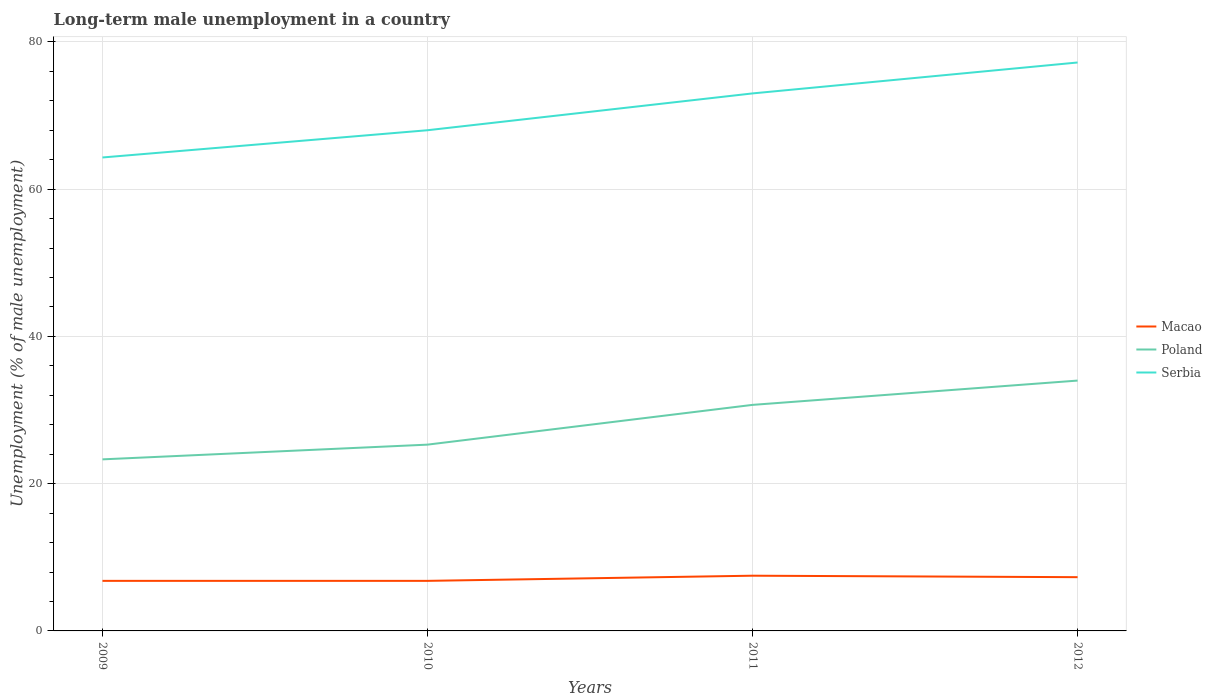Does the line corresponding to Poland intersect with the line corresponding to Macao?
Your answer should be very brief. No. Is the number of lines equal to the number of legend labels?
Offer a very short reply. Yes. Across all years, what is the maximum percentage of long-term unemployed male population in Serbia?
Your answer should be very brief. 64.3. In which year was the percentage of long-term unemployed male population in Serbia maximum?
Offer a very short reply. 2009. What is the total percentage of long-term unemployed male population in Macao in the graph?
Offer a very short reply. -0.7. What is the difference between the highest and the second highest percentage of long-term unemployed male population in Serbia?
Your response must be concise. 12.9. How many lines are there?
Offer a very short reply. 3. How many years are there in the graph?
Provide a succinct answer. 4. What is the difference between two consecutive major ticks on the Y-axis?
Your answer should be very brief. 20. Where does the legend appear in the graph?
Offer a terse response. Center right. How many legend labels are there?
Keep it short and to the point. 3. What is the title of the graph?
Make the answer very short. Long-term male unemployment in a country. What is the label or title of the Y-axis?
Your answer should be compact. Unemployment (% of male unemployment). What is the Unemployment (% of male unemployment) of Macao in 2009?
Provide a succinct answer. 6.8. What is the Unemployment (% of male unemployment) in Poland in 2009?
Your answer should be very brief. 23.3. What is the Unemployment (% of male unemployment) in Serbia in 2009?
Your answer should be compact. 64.3. What is the Unemployment (% of male unemployment) of Macao in 2010?
Provide a short and direct response. 6.8. What is the Unemployment (% of male unemployment) in Poland in 2010?
Provide a short and direct response. 25.3. What is the Unemployment (% of male unemployment) of Macao in 2011?
Your answer should be very brief. 7.5. What is the Unemployment (% of male unemployment) in Poland in 2011?
Your answer should be very brief. 30.7. What is the Unemployment (% of male unemployment) of Serbia in 2011?
Your answer should be very brief. 73. What is the Unemployment (% of male unemployment) of Macao in 2012?
Ensure brevity in your answer.  7.3. What is the Unemployment (% of male unemployment) of Serbia in 2012?
Make the answer very short. 77.2. Across all years, what is the maximum Unemployment (% of male unemployment) of Macao?
Your response must be concise. 7.5. Across all years, what is the maximum Unemployment (% of male unemployment) of Serbia?
Make the answer very short. 77.2. Across all years, what is the minimum Unemployment (% of male unemployment) of Macao?
Offer a very short reply. 6.8. Across all years, what is the minimum Unemployment (% of male unemployment) of Poland?
Ensure brevity in your answer.  23.3. Across all years, what is the minimum Unemployment (% of male unemployment) of Serbia?
Make the answer very short. 64.3. What is the total Unemployment (% of male unemployment) in Macao in the graph?
Make the answer very short. 28.4. What is the total Unemployment (% of male unemployment) of Poland in the graph?
Offer a terse response. 113.3. What is the total Unemployment (% of male unemployment) in Serbia in the graph?
Offer a very short reply. 282.5. What is the difference between the Unemployment (% of male unemployment) of Serbia in 2009 and that in 2010?
Offer a very short reply. -3.7. What is the difference between the Unemployment (% of male unemployment) of Macao in 2009 and that in 2011?
Provide a succinct answer. -0.7. What is the difference between the Unemployment (% of male unemployment) of Macao in 2009 and that in 2012?
Provide a succinct answer. -0.5. What is the difference between the Unemployment (% of male unemployment) of Macao in 2010 and that in 2011?
Offer a terse response. -0.7. What is the difference between the Unemployment (% of male unemployment) of Serbia in 2010 and that in 2011?
Offer a very short reply. -5. What is the difference between the Unemployment (% of male unemployment) of Poland in 2010 and that in 2012?
Keep it short and to the point. -8.7. What is the difference between the Unemployment (% of male unemployment) in Macao in 2011 and that in 2012?
Your response must be concise. 0.2. What is the difference between the Unemployment (% of male unemployment) of Poland in 2011 and that in 2012?
Give a very brief answer. -3.3. What is the difference between the Unemployment (% of male unemployment) of Serbia in 2011 and that in 2012?
Offer a very short reply. -4.2. What is the difference between the Unemployment (% of male unemployment) in Macao in 2009 and the Unemployment (% of male unemployment) in Poland in 2010?
Your response must be concise. -18.5. What is the difference between the Unemployment (% of male unemployment) of Macao in 2009 and the Unemployment (% of male unemployment) of Serbia in 2010?
Offer a very short reply. -61.2. What is the difference between the Unemployment (% of male unemployment) of Poland in 2009 and the Unemployment (% of male unemployment) of Serbia in 2010?
Your response must be concise. -44.7. What is the difference between the Unemployment (% of male unemployment) in Macao in 2009 and the Unemployment (% of male unemployment) in Poland in 2011?
Your answer should be very brief. -23.9. What is the difference between the Unemployment (% of male unemployment) in Macao in 2009 and the Unemployment (% of male unemployment) in Serbia in 2011?
Ensure brevity in your answer.  -66.2. What is the difference between the Unemployment (% of male unemployment) of Poland in 2009 and the Unemployment (% of male unemployment) of Serbia in 2011?
Your answer should be very brief. -49.7. What is the difference between the Unemployment (% of male unemployment) of Macao in 2009 and the Unemployment (% of male unemployment) of Poland in 2012?
Make the answer very short. -27.2. What is the difference between the Unemployment (% of male unemployment) of Macao in 2009 and the Unemployment (% of male unemployment) of Serbia in 2012?
Keep it short and to the point. -70.4. What is the difference between the Unemployment (% of male unemployment) of Poland in 2009 and the Unemployment (% of male unemployment) of Serbia in 2012?
Keep it short and to the point. -53.9. What is the difference between the Unemployment (% of male unemployment) in Macao in 2010 and the Unemployment (% of male unemployment) in Poland in 2011?
Keep it short and to the point. -23.9. What is the difference between the Unemployment (% of male unemployment) in Macao in 2010 and the Unemployment (% of male unemployment) in Serbia in 2011?
Your response must be concise. -66.2. What is the difference between the Unemployment (% of male unemployment) of Poland in 2010 and the Unemployment (% of male unemployment) of Serbia in 2011?
Provide a short and direct response. -47.7. What is the difference between the Unemployment (% of male unemployment) in Macao in 2010 and the Unemployment (% of male unemployment) in Poland in 2012?
Provide a succinct answer. -27.2. What is the difference between the Unemployment (% of male unemployment) of Macao in 2010 and the Unemployment (% of male unemployment) of Serbia in 2012?
Provide a succinct answer. -70.4. What is the difference between the Unemployment (% of male unemployment) in Poland in 2010 and the Unemployment (% of male unemployment) in Serbia in 2012?
Keep it short and to the point. -51.9. What is the difference between the Unemployment (% of male unemployment) of Macao in 2011 and the Unemployment (% of male unemployment) of Poland in 2012?
Ensure brevity in your answer.  -26.5. What is the difference between the Unemployment (% of male unemployment) in Macao in 2011 and the Unemployment (% of male unemployment) in Serbia in 2012?
Provide a short and direct response. -69.7. What is the difference between the Unemployment (% of male unemployment) in Poland in 2011 and the Unemployment (% of male unemployment) in Serbia in 2012?
Offer a terse response. -46.5. What is the average Unemployment (% of male unemployment) of Poland per year?
Provide a short and direct response. 28.32. What is the average Unemployment (% of male unemployment) in Serbia per year?
Ensure brevity in your answer.  70.62. In the year 2009, what is the difference between the Unemployment (% of male unemployment) of Macao and Unemployment (% of male unemployment) of Poland?
Keep it short and to the point. -16.5. In the year 2009, what is the difference between the Unemployment (% of male unemployment) of Macao and Unemployment (% of male unemployment) of Serbia?
Your answer should be very brief. -57.5. In the year 2009, what is the difference between the Unemployment (% of male unemployment) in Poland and Unemployment (% of male unemployment) in Serbia?
Ensure brevity in your answer.  -41. In the year 2010, what is the difference between the Unemployment (% of male unemployment) of Macao and Unemployment (% of male unemployment) of Poland?
Provide a short and direct response. -18.5. In the year 2010, what is the difference between the Unemployment (% of male unemployment) in Macao and Unemployment (% of male unemployment) in Serbia?
Provide a succinct answer. -61.2. In the year 2010, what is the difference between the Unemployment (% of male unemployment) of Poland and Unemployment (% of male unemployment) of Serbia?
Provide a short and direct response. -42.7. In the year 2011, what is the difference between the Unemployment (% of male unemployment) in Macao and Unemployment (% of male unemployment) in Poland?
Ensure brevity in your answer.  -23.2. In the year 2011, what is the difference between the Unemployment (% of male unemployment) of Macao and Unemployment (% of male unemployment) of Serbia?
Offer a terse response. -65.5. In the year 2011, what is the difference between the Unemployment (% of male unemployment) of Poland and Unemployment (% of male unemployment) of Serbia?
Give a very brief answer. -42.3. In the year 2012, what is the difference between the Unemployment (% of male unemployment) in Macao and Unemployment (% of male unemployment) in Poland?
Your response must be concise. -26.7. In the year 2012, what is the difference between the Unemployment (% of male unemployment) of Macao and Unemployment (% of male unemployment) of Serbia?
Ensure brevity in your answer.  -69.9. In the year 2012, what is the difference between the Unemployment (% of male unemployment) of Poland and Unemployment (% of male unemployment) of Serbia?
Your answer should be very brief. -43.2. What is the ratio of the Unemployment (% of male unemployment) of Macao in 2009 to that in 2010?
Offer a terse response. 1. What is the ratio of the Unemployment (% of male unemployment) in Poland in 2009 to that in 2010?
Your answer should be very brief. 0.92. What is the ratio of the Unemployment (% of male unemployment) of Serbia in 2009 to that in 2010?
Make the answer very short. 0.95. What is the ratio of the Unemployment (% of male unemployment) in Macao in 2009 to that in 2011?
Keep it short and to the point. 0.91. What is the ratio of the Unemployment (% of male unemployment) of Poland in 2009 to that in 2011?
Keep it short and to the point. 0.76. What is the ratio of the Unemployment (% of male unemployment) in Serbia in 2009 to that in 2011?
Provide a succinct answer. 0.88. What is the ratio of the Unemployment (% of male unemployment) of Macao in 2009 to that in 2012?
Your answer should be compact. 0.93. What is the ratio of the Unemployment (% of male unemployment) of Poland in 2009 to that in 2012?
Ensure brevity in your answer.  0.69. What is the ratio of the Unemployment (% of male unemployment) in Serbia in 2009 to that in 2012?
Your answer should be very brief. 0.83. What is the ratio of the Unemployment (% of male unemployment) in Macao in 2010 to that in 2011?
Your answer should be compact. 0.91. What is the ratio of the Unemployment (% of male unemployment) in Poland in 2010 to that in 2011?
Offer a very short reply. 0.82. What is the ratio of the Unemployment (% of male unemployment) in Serbia in 2010 to that in 2011?
Your answer should be compact. 0.93. What is the ratio of the Unemployment (% of male unemployment) in Macao in 2010 to that in 2012?
Make the answer very short. 0.93. What is the ratio of the Unemployment (% of male unemployment) in Poland in 2010 to that in 2012?
Provide a succinct answer. 0.74. What is the ratio of the Unemployment (% of male unemployment) in Serbia in 2010 to that in 2012?
Make the answer very short. 0.88. What is the ratio of the Unemployment (% of male unemployment) of Macao in 2011 to that in 2012?
Your answer should be compact. 1.03. What is the ratio of the Unemployment (% of male unemployment) of Poland in 2011 to that in 2012?
Offer a terse response. 0.9. What is the ratio of the Unemployment (% of male unemployment) of Serbia in 2011 to that in 2012?
Keep it short and to the point. 0.95. 